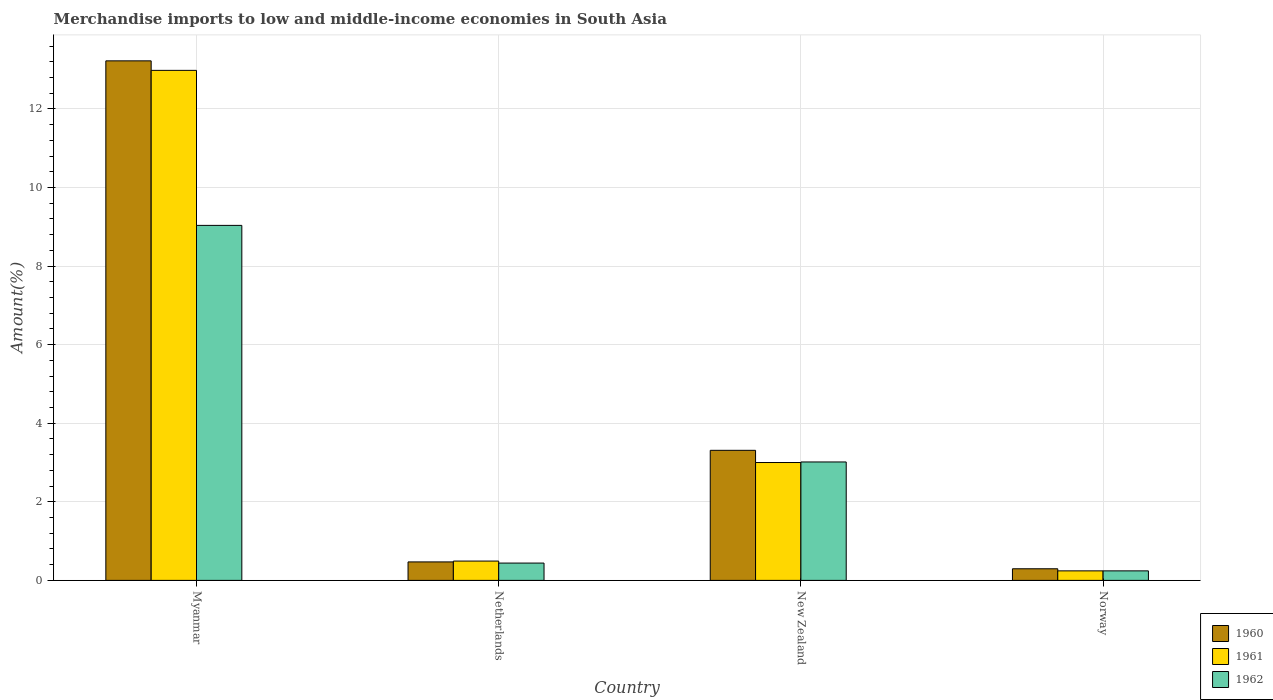How many different coloured bars are there?
Provide a succinct answer. 3. How many groups of bars are there?
Make the answer very short. 4. Are the number of bars per tick equal to the number of legend labels?
Your response must be concise. Yes. Are the number of bars on each tick of the X-axis equal?
Offer a very short reply. Yes. What is the label of the 1st group of bars from the left?
Keep it short and to the point. Myanmar. In how many cases, is the number of bars for a given country not equal to the number of legend labels?
Provide a succinct answer. 0. What is the percentage of amount earned from merchandise imports in 1961 in New Zealand?
Your response must be concise. 3. Across all countries, what is the maximum percentage of amount earned from merchandise imports in 1961?
Make the answer very short. 12.98. Across all countries, what is the minimum percentage of amount earned from merchandise imports in 1962?
Give a very brief answer. 0.24. In which country was the percentage of amount earned from merchandise imports in 1961 maximum?
Give a very brief answer. Myanmar. In which country was the percentage of amount earned from merchandise imports in 1960 minimum?
Your response must be concise. Norway. What is the total percentage of amount earned from merchandise imports in 1962 in the graph?
Offer a terse response. 12.73. What is the difference between the percentage of amount earned from merchandise imports in 1961 in Netherlands and that in Norway?
Your response must be concise. 0.25. What is the difference between the percentage of amount earned from merchandise imports in 1961 in New Zealand and the percentage of amount earned from merchandise imports in 1962 in Myanmar?
Your response must be concise. -6.04. What is the average percentage of amount earned from merchandise imports in 1961 per country?
Keep it short and to the point. 4.18. What is the difference between the percentage of amount earned from merchandise imports of/in 1960 and percentage of amount earned from merchandise imports of/in 1961 in Norway?
Provide a short and direct response. 0.05. What is the ratio of the percentage of amount earned from merchandise imports in 1961 in Myanmar to that in Norway?
Make the answer very short. 53.54. What is the difference between the highest and the second highest percentage of amount earned from merchandise imports in 1961?
Provide a succinct answer. -2.51. What is the difference between the highest and the lowest percentage of amount earned from merchandise imports in 1962?
Offer a terse response. 8.79. In how many countries, is the percentage of amount earned from merchandise imports in 1960 greater than the average percentage of amount earned from merchandise imports in 1960 taken over all countries?
Your answer should be very brief. 1. What does the 2nd bar from the left in Netherlands represents?
Provide a succinct answer. 1961. What does the 2nd bar from the right in Myanmar represents?
Provide a succinct answer. 1961. How many bars are there?
Provide a succinct answer. 12. Does the graph contain grids?
Make the answer very short. Yes. How are the legend labels stacked?
Your answer should be compact. Vertical. What is the title of the graph?
Give a very brief answer. Merchandise imports to low and middle-income economies in South Asia. Does "1960" appear as one of the legend labels in the graph?
Give a very brief answer. Yes. What is the label or title of the Y-axis?
Provide a succinct answer. Amount(%). What is the Amount(%) of 1960 in Myanmar?
Give a very brief answer. 13.22. What is the Amount(%) of 1961 in Myanmar?
Make the answer very short. 12.98. What is the Amount(%) in 1962 in Myanmar?
Give a very brief answer. 9.04. What is the Amount(%) in 1960 in Netherlands?
Offer a very short reply. 0.47. What is the Amount(%) of 1961 in Netherlands?
Offer a terse response. 0.49. What is the Amount(%) in 1962 in Netherlands?
Provide a succinct answer. 0.44. What is the Amount(%) in 1960 in New Zealand?
Offer a very short reply. 3.31. What is the Amount(%) of 1961 in New Zealand?
Provide a short and direct response. 3. What is the Amount(%) in 1962 in New Zealand?
Your answer should be very brief. 3.01. What is the Amount(%) of 1960 in Norway?
Ensure brevity in your answer.  0.3. What is the Amount(%) of 1961 in Norway?
Offer a terse response. 0.24. What is the Amount(%) of 1962 in Norway?
Keep it short and to the point. 0.24. Across all countries, what is the maximum Amount(%) of 1960?
Give a very brief answer. 13.22. Across all countries, what is the maximum Amount(%) of 1961?
Your response must be concise. 12.98. Across all countries, what is the maximum Amount(%) of 1962?
Your answer should be compact. 9.04. Across all countries, what is the minimum Amount(%) in 1960?
Keep it short and to the point. 0.3. Across all countries, what is the minimum Amount(%) in 1961?
Ensure brevity in your answer.  0.24. Across all countries, what is the minimum Amount(%) in 1962?
Your response must be concise. 0.24. What is the total Amount(%) in 1960 in the graph?
Make the answer very short. 17.3. What is the total Amount(%) in 1961 in the graph?
Offer a terse response. 16.72. What is the total Amount(%) of 1962 in the graph?
Your response must be concise. 12.73. What is the difference between the Amount(%) of 1960 in Myanmar and that in Netherlands?
Ensure brevity in your answer.  12.75. What is the difference between the Amount(%) of 1961 in Myanmar and that in Netherlands?
Provide a succinct answer. 12.49. What is the difference between the Amount(%) in 1962 in Myanmar and that in Netherlands?
Offer a very short reply. 8.6. What is the difference between the Amount(%) of 1960 in Myanmar and that in New Zealand?
Provide a succinct answer. 9.91. What is the difference between the Amount(%) in 1961 in Myanmar and that in New Zealand?
Offer a terse response. 9.98. What is the difference between the Amount(%) of 1962 in Myanmar and that in New Zealand?
Your response must be concise. 6.02. What is the difference between the Amount(%) in 1960 in Myanmar and that in Norway?
Ensure brevity in your answer.  12.93. What is the difference between the Amount(%) in 1961 in Myanmar and that in Norway?
Give a very brief answer. 12.74. What is the difference between the Amount(%) in 1962 in Myanmar and that in Norway?
Give a very brief answer. 8.79. What is the difference between the Amount(%) of 1960 in Netherlands and that in New Zealand?
Your answer should be very brief. -2.84. What is the difference between the Amount(%) in 1961 in Netherlands and that in New Zealand?
Your answer should be compact. -2.51. What is the difference between the Amount(%) in 1962 in Netherlands and that in New Zealand?
Offer a terse response. -2.57. What is the difference between the Amount(%) in 1960 in Netherlands and that in Norway?
Provide a succinct answer. 0.17. What is the difference between the Amount(%) in 1961 in Netherlands and that in Norway?
Ensure brevity in your answer.  0.25. What is the difference between the Amount(%) of 1962 in Netherlands and that in Norway?
Keep it short and to the point. 0.2. What is the difference between the Amount(%) of 1960 in New Zealand and that in Norway?
Give a very brief answer. 3.02. What is the difference between the Amount(%) of 1961 in New Zealand and that in Norway?
Provide a short and direct response. 2.76. What is the difference between the Amount(%) of 1962 in New Zealand and that in Norway?
Keep it short and to the point. 2.77. What is the difference between the Amount(%) of 1960 in Myanmar and the Amount(%) of 1961 in Netherlands?
Offer a terse response. 12.73. What is the difference between the Amount(%) of 1960 in Myanmar and the Amount(%) of 1962 in Netherlands?
Your answer should be compact. 12.78. What is the difference between the Amount(%) of 1961 in Myanmar and the Amount(%) of 1962 in Netherlands?
Keep it short and to the point. 12.54. What is the difference between the Amount(%) of 1960 in Myanmar and the Amount(%) of 1961 in New Zealand?
Your response must be concise. 10.22. What is the difference between the Amount(%) in 1960 in Myanmar and the Amount(%) in 1962 in New Zealand?
Provide a short and direct response. 10.21. What is the difference between the Amount(%) of 1961 in Myanmar and the Amount(%) of 1962 in New Zealand?
Offer a very short reply. 9.97. What is the difference between the Amount(%) of 1960 in Myanmar and the Amount(%) of 1961 in Norway?
Your answer should be very brief. 12.98. What is the difference between the Amount(%) in 1960 in Myanmar and the Amount(%) in 1962 in Norway?
Provide a short and direct response. 12.98. What is the difference between the Amount(%) of 1961 in Myanmar and the Amount(%) of 1962 in Norway?
Make the answer very short. 12.74. What is the difference between the Amount(%) in 1960 in Netherlands and the Amount(%) in 1961 in New Zealand?
Offer a terse response. -2.53. What is the difference between the Amount(%) in 1960 in Netherlands and the Amount(%) in 1962 in New Zealand?
Offer a very short reply. -2.54. What is the difference between the Amount(%) of 1961 in Netherlands and the Amount(%) of 1962 in New Zealand?
Make the answer very short. -2.52. What is the difference between the Amount(%) in 1960 in Netherlands and the Amount(%) in 1961 in Norway?
Your answer should be very brief. 0.23. What is the difference between the Amount(%) in 1960 in Netherlands and the Amount(%) in 1962 in Norway?
Your answer should be compact. 0.23. What is the difference between the Amount(%) in 1961 in Netherlands and the Amount(%) in 1962 in Norway?
Make the answer very short. 0.25. What is the difference between the Amount(%) in 1960 in New Zealand and the Amount(%) in 1961 in Norway?
Ensure brevity in your answer.  3.07. What is the difference between the Amount(%) of 1960 in New Zealand and the Amount(%) of 1962 in Norway?
Keep it short and to the point. 3.07. What is the difference between the Amount(%) in 1961 in New Zealand and the Amount(%) in 1962 in Norway?
Your answer should be very brief. 2.76. What is the average Amount(%) of 1960 per country?
Offer a very short reply. 4.33. What is the average Amount(%) of 1961 per country?
Keep it short and to the point. 4.18. What is the average Amount(%) in 1962 per country?
Your answer should be very brief. 3.18. What is the difference between the Amount(%) of 1960 and Amount(%) of 1961 in Myanmar?
Your response must be concise. 0.24. What is the difference between the Amount(%) of 1960 and Amount(%) of 1962 in Myanmar?
Your answer should be very brief. 4.19. What is the difference between the Amount(%) of 1961 and Amount(%) of 1962 in Myanmar?
Provide a succinct answer. 3.95. What is the difference between the Amount(%) of 1960 and Amount(%) of 1961 in Netherlands?
Make the answer very short. -0.02. What is the difference between the Amount(%) of 1960 and Amount(%) of 1962 in Netherlands?
Your response must be concise. 0.03. What is the difference between the Amount(%) of 1961 and Amount(%) of 1962 in Netherlands?
Offer a terse response. 0.05. What is the difference between the Amount(%) of 1960 and Amount(%) of 1961 in New Zealand?
Provide a short and direct response. 0.31. What is the difference between the Amount(%) of 1960 and Amount(%) of 1962 in New Zealand?
Give a very brief answer. 0.3. What is the difference between the Amount(%) of 1961 and Amount(%) of 1962 in New Zealand?
Make the answer very short. -0.01. What is the difference between the Amount(%) in 1960 and Amount(%) in 1961 in Norway?
Your answer should be compact. 0.05. What is the difference between the Amount(%) of 1960 and Amount(%) of 1962 in Norway?
Offer a terse response. 0.05. What is the ratio of the Amount(%) in 1960 in Myanmar to that in Netherlands?
Your answer should be very brief. 28.12. What is the ratio of the Amount(%) in 1961 in Myanmar to that in Netherlands?
Offer a very short reply. 26.4. What is the ratio of the Amount(%) of 1962 in Myanmar to that in Netherlands?
Keep it short and to the point. 20.5. What is the ratio of the Amount(%) in 1960 in Myanmar to that in New Zealand?
Ensure brevity in your answer.  3.99. What is the ratio of the Amount(%) of 1961 in Myanmar to that in New Zealand?
Your answer should be very brief. 4.33. What is the ratio of the Amount(%) of 1962 in Myanmar to that in New Zealand?
Ensure brevity in your answer.  3. What is the ratio of the Amount(%) in 1960 in Myanmar to that in Norway?
Make the answer very short. 44.71. What is the ratio of the Amount(%) in 1961 in Myanmar to that in Norway?
Keep it short and to the point. 53.54. What is the ratio of the Amount(%) in 1962 in Myanmar to that in Norway?
Provide a succinct answer. 37.28. What is the ratio of the Amount(%) in 1960 in Netherlands to that in New Zealand?
Your response must be concise. 0.14. What is the ratio of the Amount(%) in 1961 in Netherlands to that in New Zealand?
Your answer should be very brief. 0.16. What is the ratio of the Amount(%) of 1962 in Netherlands to that in New Zealand?
Offer a terse response. 0.15. What is the ratio of the Amount(%) of 1960 in Netherlands to that in Norway?
Offer a terse response. 1.59. What is the ratio of the Amount(%) of 1961 in Netherlands to that in Norway?
Give a very brief answer. 2.03. What is the ratio of the Amount(%) in 1962 in Netherlands to that in Norway?
Your answer should be compact. 1.82. What is the ratio of the Amount(%) of 1960 in New Zealand to that in Norway?
Make the answer very short. 11.19. What is the ratio of the Amount(%) of 1961 in New Zealand to that in Norway?
Your response must be concise. 12.37. What is the ratio of the Amount(%) in 1962 in New Zealand to that in Norway?
Offer a very short reply. 12.44. What is the difference between the highest and the second highest Amount(%) of 1960?
Make the answer very short. 9.91. What is the difference between the highest and the second highest Amount(%) in 1961?
Offer a terse response. 9.98. What is the difference between the highest and the second highest Amount(%) of 1962?
Your answer should be very brief. 6.02. What is the difference between the highest and the lowest Amount(%) in 1960?
Your response must be concise. 12.93. What is the difference between the highest and the lowest Amount(%) of 1961?
Offer a terse response. 12.74. What is the difference between the highest and the lowest Amount(%) of 1962?
Give a very brief answer. 8.79. 